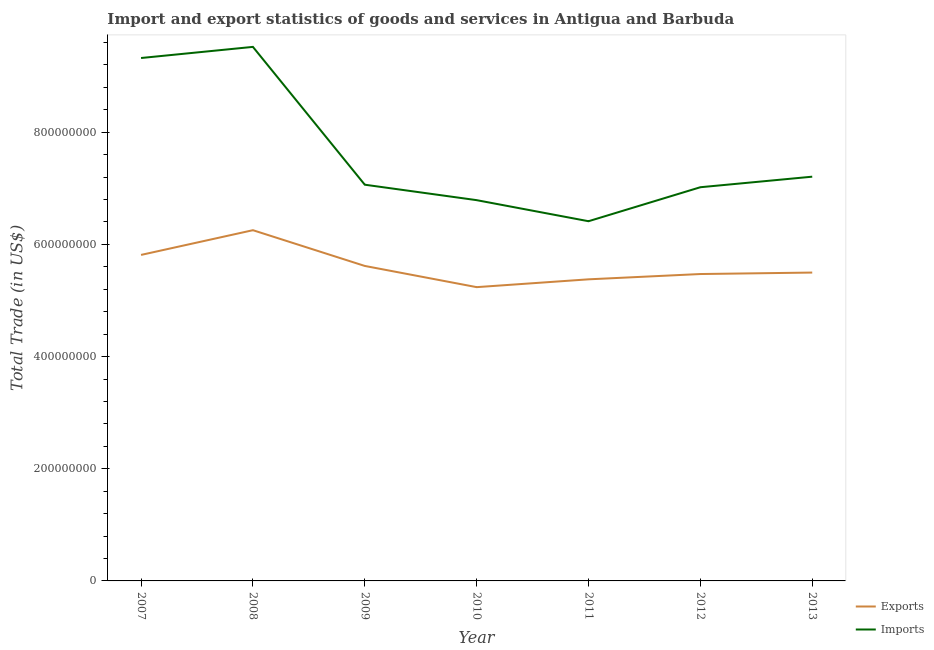What is the export of goods and services in 2012?
Your answer should be compact. 5.47e+08. Across all years, what is the maximum export of goods and services?
Provide a short and direct response. 6.25e+08. Across all years, what is the minimum imports of goods and services?
Your answer should be compact. 6.41e+08. In which year was the imports of goods and services maximum?
Make the answer very short. 2008. In which year was the imports of goods and services minimum?
Provide a short and direct response. 2011. What is the total imports of goods and services in the graph?
Ensure brevity in your answer.  5.33e+09. What is the difference between the imports of goods and services in 2008 and that in 2012?
Offer a terse response. 2.50e+08. What is the difference between the imports of goods and services in 2009 and the export of goods and services in 2013?
Offer a terse response. 1.57e+08. What is the average export of goods and services per year?
Your answer should be compact. 5.61e+08. In the year 2007, what is the difference between the export of goods and services and imports of goods and services?
Your response must be concise. -3.51e+08. In how many years, is the imports of goods and services greater than 240000000 US$?
Provide a short and direct response. 7. What is the ratio of the imports of goods and services in 2007 to that in 2010?
Make the answer very short. 1.37. What is the difference between the highest and the second highest export of goods and services?
Your answer should be compact. 4.41e+07. What is the difference between the highest and the lowest export of goods and services?
Give a very brief answer. 1.02e+08. In how many years, is the imports of goods and services greater than the average imports of goods and services taken over all years?
Make the answer very short. 2. Does the export of goods and services monotonically increase over the years?
Make the answer very short. No. Is the export of goods and services strictly greater than the imports of goods and services over the years?
Your answer should be very brief. No. Is the export of goods and services strictly less than the imports of goods and services over the years?
Keep it short and to the point. Yes. How many years are there in the graph?
Your answer should be compact. 7. What is the difference between two consecutive major ticks on the Y-axis?
Your response must be concise. 2.00e+08. Are the values on the major ticks of Y-axis written in scientific E-notation?
Keep it short and to the point. No. Does the graph contain grids?
Offer a very short reply. No. Where does the legend appear in the graph?
Your answer should be very brief. Bottom right. How are the legend labels stacked?
Offer a terse response. Vertical. What is the title of the graph?
Ensure brevity in your answer.  Import and export statistics of goods and services in Antigua and Barbuda. Does "Foreign liabilities" appear as one of the legend labels in the graph?
Offer a very short reply. No. What is the label or title of the X-axis?
Offer a very short reply. Year. What is the label or title of the Y-axis?
Your answer should be very brief. Total Trade (in US$). What is the Total Trade (in US$) in Exports in 2007?
Your response must be concise. 5.81e+08. What is the Total Trade (in US$) in Imports in 2007?
Provide a short and direct response. 9.32e+08. What is the Total Trade (in US$) of Exports in 2008?
Give a very brief answer. 6.25e+08. What is the Total Trade (in US$) of Imports in 2008?
Keep it short and to the point. 9.52e+08. What is the Total Trade (in US$) of Exports in 2009?
Your response must be concise. 5.62e+08. What is the Total Trade (in US$) in Imports in 2009?
Your response must be concise. 7.06e+08. What is the Total Trade (in US$) of Exports in 2010?
Your response must be concise. 5.24e+08. What is the Total Trade (in US$) of Imports in 2010?
Your answer should be very brief. 6.79e+08. What is the Total Trade (in US$) of Exports in 2011?
Provide a short and direct response. 5.38e+08. What is the Total Trade (in US$) of Imports in 2011?
Your answer should be very brief. 6.41e+08. What is the Total Trade (in US$) of Exports in 2012?
Offer a terse response. 5.47e+08. What is the Total Trade (in US$) of Imports in 2012?
Offer a very short reply. 7.02e+08. What is the Total Trade (in US$) of Exports in 2013?
Your answer should be very brief. 5.50e+08. What is the Total Trade (in US$) of Imports in 2013?
Offer a very short reply. 7.21e+08. Across all years, what is the maximum Total Trade (in US$) in Exports?
Offer a terse response. 6.25e+08. Across all years, what is the maximum Total Trade (in US$) in Imports?
Make the answer very short. 9.52e+08. Across all years, what is the minimum Total Trade (in US$) of Exports?
Provide a short and direct response. 5.24e+08. Across all years, what is the minimum Total Trade (in US$) in Imports?
Your response must be concise. 6.41e+08. What is the total Total Trade (in US$) in Exports in the graph?
Provide a succinct answer. 3.93e+09. What is the total Total Trade (in US$) in Imports in the graph?
Your answer should be compact. 5.33e+09. What is the difference between the Total Trade (in US$) in Exports in 2007 and that in 2008?
Offer a very short reply. -4.41e+07. What is the difference between the Total Trade (in US$) of Imports in 2007 and that in 2008?
Ensure brevity in your answer.  -1.98e+07. What is the difference between the Total Trade (in US$) of Exports in 2007 and that in 2009?
Provide a short and direct response. 1.97e+07. What is the difference between the Total Trade (in US$) in Imports in 2007 and that in 2009?
Provide a succinct answer. 2.26e+08. What is the difference between the Total Trade (in US$) in Exports in 2007 and that in 2010?
Offer a terse response. 5.75e+07. What is the difference between the Total Trade (in US$) in Imports in 2007 and that in 2010?
Offer a terse response. 2.53e+08. What is the difference between the Total Trade (in US$) in Exports in 2007 and that in 2011?
Your answer should be compact. 4.35e+07. What is the difference between the Total Trade (in US$) in Imports in 2007 and that in 2011?
Keep it short and to the point. 2.91e+08. What is the difference between the Total Trade (in US$) in Exports in 2007 and that in 2012?
Provide a succinct answer. 3.41e+07. What is the difference between the Total Trade (in US$) in Imports in 2007 and that in 2012?
Ensure brevity in your answer.  2.30e+08. What is the difference between the Total Trade (in US$) in Exports in 2007 and that in 2013?
Offer a terse response. 3.15e+07. What is the difference between the Total Trade (in US$) in Imports in 2007 and that in 2013?
Provide a short and direct response. 2.12e+08. What is the difference between the Total Trade (in US$) in Exports in 2008 and that in 2009?
Your answer should be compact. 6.37e+07. What is the difference between the Total Trade (in US$) of Imports in 2008 and that in 2009?
Ensure brevity in your answer.  2.46e+08. What is the difference between the Total Trade (in US$) of Exports in 2008 and that in 2010?
Give a very brief answer. 1.02e+08. What is the difference between the Total Trade (in US$) in Imports in 2008 and that in 2010?
Ensure brevity in your answer.  2.73e+08. What is the difference between the Total Trade (in US$) in Exports in 2008 and that in 2011?
Keep it short and to the point. 8.76e+07. What is the difference between the Total Trade (in US$) of Imports in 2008 and that in 2011?
Your answer should be compact. 3.11e+08. What is the difference between the Total Trade (in US$) of Exports in 2008 and that in 2012?
Your answer should be compact. 7.82e+07. What is the difference between the Total Trade (in US$) in Imports in 2008 and that in 2012?
Offer a very short reply. 2.50e+08. What is the difference between the Total Trade (in US$) in Exports in 2008 and that in 2013?
Give a very brief answer. 7.56e+07. What is the difference between the Total Trade (in US$) of Imports in 2008 and that in 2013?
Offer a terse response. 2.31e+08. What is the difference between the Total Trade (in US$) in Exports in 2009 and that in 2010?
Give a very brief answer. 3.78e+07. What is the difference between the Total Trade (in US$) in Imports in 2009 and that in 2010?
Provide a short and direct response. 2.75e+07. What is the difference between the Total Trade (in US$) in Exports in 2009 and that in 2011?
Your response must be concise. 2.39e+07. What is the difference between the Total Trade (in US$) of Imports in 2009 and that in 2011?
Keep it short and to the point. 6.51e+07. What is the difference between the Total Trade (in US$) in Exports in 2009 and that in 2012?
Provide a short and direct response. 1.44e+07. What is the difference between the Total Trade (in US$) in Imports in 2009 and that in 2012?
Provide a succinct answer. 4.49e+06. What is the difference between the Total Trade (in US$) of Exports in 2009 and that in 2013?
Offer a very short reply. 1.18e+07. What is the difference between the Total Trade (in US$) in Imports in 2009 and that in 2013?
Give a very brief answer. -1.43e+07. What is the difference between the Total Trade (in US$) of Exports in 2010 and that in 2011?
Make the answer very short. -1.39e+07. What is the difference between the Total Trade (in US$) in Imports in 2010 and that in 2011?
Provide a short and direct response. 3.76e+07. What is the difference between the Total Trade (in US$) in Exports in 2010 and that in 2012?
Offer a very short reply. -2.34e+07. What is the difference between the Total Trade (in US$) of Imports in 2010 and that in 2012?
Your response must be concise. -2.31e+07. What is the difference between the Total Trade (in US$) of Exports in 2010 and that in 2013?
Keep it short and to the point. -2.60e+07. What is the difference between the Total Trade (in US$) in Imports in 2010 and that in 2013?
Provide a short and direct response. -4.19e+07. What is the difference between the Total Trade (in US$) in Exports in 2011 and that in 2012?
Give a very brief answer. -9.44e+06. What is the difference between the Total Trade (in US$) in Imports in 2011 and that in 2012?
Provide a succinct answer. -6.06e+07. What is the difference between the Total Trade (in US$) of Exports in 2011 and that in 2013?
Your answer should be compact. -1.21e+07. What is the difference between the Total Trade (in US$) in Imports in 2011 and that in 2013?
Provide a succinct answer. -7.94e+07. What is the difference between the Total Trade (in US$) in Exports in 2012 and that in 2013?
Your answer should be compact. -2.62e+06. What is the difference between the Total Trade (in US$) in Imports in 2012 and that in 2013?
Offer a very short reply. -1.88e+07. What is the difference between the Total Trade (in US$) in Exports in 2007 and the Total Trade (in US$) in Imports in 2008?
Provide a short and direct response. -3.71e+08. What is the difference between the Total Trade (in US$) of Exports in 2007 and the Total Trade (in US$) of Imports in 2009?
Provide a succinct answer. -1.25e+08. What is the difference between the Total Trade (in US$) in Exports in 2007 and the Total Trade (in US$) in Imports in 2010?
Your answer should be very brief. -9.76e+07. What is the difference between the Total Trade (in US$) in Exports in 2007 and the Total Trade (in US$) in Imports in 2011?
Ensure brevity in your answer.  -6.01e+07. What is the difference between the Total Trade (in US$) of Exports in 2007 and the Total Trade (in US$) of Imports in 2012?
Keep it short and to the point. -1.21e+08. What is the difference between the Total Trade (in US$) of Exports in 2007 and the Total Trade (in US$) of Imports in 2013?
Offer a terse response. -1.39e+08. What is the difference between the Total Trade (in US$) in Exports in 2008 and the Total Trade (in US$) in Imports in 2009?
Make the answer very short. -8.11e+07. What is the difference between the Total Trade (in US$) in Exports in 2008 and the Total Trade (in US$) in Imports in 2010?
Provide a succinct answer. -5.36e+07. What is the difference between the Total Trade (in US$) in Exports in 2008 and the Total Trade (in US$) in Imports in 2011?
Your response must be concise. -1.60e+07. What is the difference between the Total Trade (in US$) of Exports in 2008 and the Total Trade (in US$) of Imports in 2012?
Provide a short and direct response. -7.66e+07. What is the difference between the Total Trade (in US$) of Exports in 2008 and the Total Trade (in US$) of Imports in 2013?
Your response must be concise. -9.54e+07. What is the difference between the Total Trade (in US$) of Exports in 2009 and the Total Trade (in US$) of Imports in 2010?
Your answer should be very brief. -1.17e+08. What is the difference between the Total Trade (in US$) in Exports in 2009 and the Total Trade (in US$) in Imports in 2011?
Make the answer very short. -7.97e+07. What is the difference between the Total Trade (in US$) of Exports in 2009 and the Total Trade (in US$) of Imports in 2012?
Make the answer very short. -1.40e+08. What is the difference between the Total Trade (in US$) of Exports in 2009 and the Total Trade (in US$) of Imports in 2013?
Offer a very short reply. -1.59e+08. What is the difference between the Total Trade (in US$) in Exports in 2010 and the Total Trade (in US$) in Imports in 2011?
Provide a short and direct response. -1.18e+08. What is the difference between the Total Trade (in US$) of Exports in 2010 and the Total Trade (in US$) of Imports in 2012?
Provide a succinct answer. -1.78e+08. What is the difference between the Total Trade (in US$) in Exports in 2010 and the Total Trade (in US$) in Imports in 2013?
Offer a very short reply. -1.97e+08. What is the difference between the Total Trade (in US$) in Exports in 2011 and the Total Trade (in US$) in Imports in 2012?
Offer a terse response. -1.64e+08. What is the difference between the Total Trade (in US$) of Exports in 2011 and the Total Trade (in US$) of Imports in 2013?
Your response must be concise. -1.83e+08. What is the difference between the Total Trade (in US$) in Exports in 2012 and the Total Trade (in US$) in Imports in 2013?
Your response must be concise. -1.74e+08. What is the average Total Trade (in US$) in Exports per year?
Offer a terse response. 5.61e+08. What is the average Total Trade (in US$) in Imports per year?
Give a very brief answer. 7.62e+08. In the year 2007, what is the difference between the Total Trade (in US$) of Exports and Total Trade (in US$) of Imports?
Keep it short and to the point. -3.51e+08. In the year 2008, what is the difference between the Total Trade (in US$) in Exports and Total Trade (in US$) in Imports?
Your answer should be compact. -3.27e+08. In the year 2009, what is the difference between the Total Trade (in US$) in Exports and Total Trade (in US$) in Imports?
Provide a short and direct response. -1.45e+08. In the year 2010, what is the difference between the Total Trade (in US$) of Exports and Total Trade (in US$) of Imports?
Your response must be concise. -1.55e+08. In the year 2011, what is the difference between the Total Trade (in US$) of Exports and Total Trade (in US$) of Imports?
Make the answer very short. -1.04e+08. In the year 2012, what is the difference between the Total Trade (in US$) of Exports and Total Trade (in US$) of Imports?
Provide a short and direct response. -1.55e+08. In the year 2013, what is the difference between the Total Trade (in US$) in Exports and Total Trade (in US$) in Imports?
Provide a succinct answer. -1.71e+08. What is the ratio of the Total Trade (in US$) in Exports in 2007 to that in 2008?
Give a very brief answer. 0.93. What is the ratio of the Total Trade (in US$) of Imports in 2007 to that in 2008?
Keep it short and to the point. 0.98. What is the ratio of the Total Trade (in US$) in Exports in 2007 to that in 2009?
Your answer should be compact. 1.03. What is the ratio of the Total Trade (in US$) in Imports in 2007 to that in 2009?
Offer a very short reply. 1.32. What is the ratio of the Total Trade (in US$) in Exports in 2007 to that in 2010?
Offer a very short reply. 1.11. What is the ratio of the Total Trade (in US$) of Imports in 2007 to that in 2010?
Keep it short and to the point. 1.37. What is the ratio of the Total Trade (in US$) of Exports in 2007 to that in 2011?
Offer a very short reply. 1.08. What is the ratio of the Total Trade (in US$) of Imports in 2007 to that in 2011?
Offer a very short reply. 1.45. What is the ratio of the Total Trade (in US$) of Exports in 2007 to that in 2012?
Provide a succinct answer. 1.06. What is the ratio of the Total Trade (in US$) of Imports in 2007 to that in 2012?
Provide a short and direct response. 1.33. What is the ratio of the Total Trade (in US$) in Exports in 2007 to that in 2013?
Provide a succinct answer. 1.06. What is the ratio of the Total Trade (in US$) of Imports in 2007 to that in 2013?
Offer a very short reply. 1.29. What is the ratio of the Total Trade (in US$) of Exports in 2008 to that in 2009?
Make the answer very short. 1.11. What is the ratio of the Total Trade (in US$) in Imports in 2008 to that in 2009?
Keep it short and to the point. 1.35. What is the ratio of the Total Trade (in US$) in Exports in 2008 to that in 2010?
Ensure brevity in your answer.  1.19. What is the ratio of the Total Trade (in US$) in Imports in 2008 to that in 2010?
Offer a terse response. 1.4. What is the ratio of the Total Trade (in US$) of Exports in 2008 to that in 2011?
Your response must be concise. 1.16. What is the ratio of the Total Trade (in US$) in Imports in 2008 to that in 2011?
Give a very brief answer. 1.48. What is the ratio of the Total Trade (in US$) of Exports in 2008 to that in 2012?
Keep it short and to the point. 1.14. What is the ratio of the Total Trade (in US$) of Imports in 2008 to that in 2012?
Provide a succinct answer. 1.36. What is the ratio of the Total Trade (in US$) in Exports in 2008 to that in 2013?
Offer a very short reply. 1.14. What is the ratio of the Total Trade (in US$) of Imports in 2008 to that in 2013?
Provide a short and direct response. 1.32. What is the ratio of the Total Trade (in US$) in Exports in 2009 to that in 2010?
Your response must be concise. 1.07. What is the ratio of the Total Trade (in US$) of Imports in 2009 to that in 2010?
Ensure brevity in your answer.  1.04. What is the ratio of the Total Trade (in US$) in Exports in 2009 to that in 2011?
Offer a terse response. 1.04. What is the ratio of the Total Trade (in US$) in Imports in 2009 to that in 2011?
Give a very brief answer. 1.1. What is the ratio of the Total Trade (in US$) in Exports in 2009 to that in 2012?
Make the answer very short. 1.03. What is the ratio of the Total Trade (in US$) of Imports in 2009 to that in 2012?
Offer a very short reply. 1.01. What is the ratio of the Total Trade (in US$) in Exports in 2009 to that in 2013?
Keep it short and to the point. 1.02. What is the ratio of the Total Trade (in US$) of Imports in 2009 to that in 2013?
Keep it short and to the point. 0.98. What is the ratio of the Total Trade (in US$) in Exports in 2010 to that in 2011?
Your answer should be very brief. 0.97. What is the ratio of the Total Trade (in US$) of Imports in 2010 to that in 2011?
Your answer should be compact. 1.06. What is the ratio of the Total Trade (in US$) of Exports in 2010 to that in 2012?
Your answer should be very brief. 0.96. What is the ratio of the Total Trade (in US$) of Imports in 2010 to that in 2012?
Your answer should be compact. 0.97. What is the ratio of the Total Trade (in US$) of Exports in 2010 to that in 2013?
Offer a terse response. 0.95. What is the ratio of the Total Trade (in US$) of Imports in 2010 to that in 2013?
Your response must be concise. 0.94. What is the ratio of the Total Trade (in US$) of Exports in 2011 to that in 2012?
Provide a succinct answer. 0.98. What is the ratio of the Total Trade (in US$) of Imports in 2011 to that in 2012?
Keep it short and to the point. 0.91. What is the ratio of the Total Trade (in US$) of Exports in 2011 to that in 2013?
Your response must be concise. 0.98. What is the ratio of the Total Trade (in US$) in Imports in 2011 to that in 2013?
Make the answer very short. 0.89. What is the ratio of the Total Trade (in US$) of Exports in 2012 to that in 2013?
Ensure brevity in your answer.  1. What is the ratio of the Total Trade (in US$) of Imports in 2012 to that in 2013?
Make the answer very short. 0.97. What is the difference between the highest and the second highest Total Trade (in US$) in Exports?
Keep it short and to the point. 4.41e+07. What is the difference between the highest and the second highest Total Trade (in US$) of Imports?
Offer a very short reply. 1.98e+07. What is the difference between the highest and the lowest Total Trade (in US$) of Exports?
Your answer should be compact. 1.02e+08. What is the difference between the highest and the lowest Total Trade (in US$) of Imports?
Your answer should be compact. 3.11e+08. 